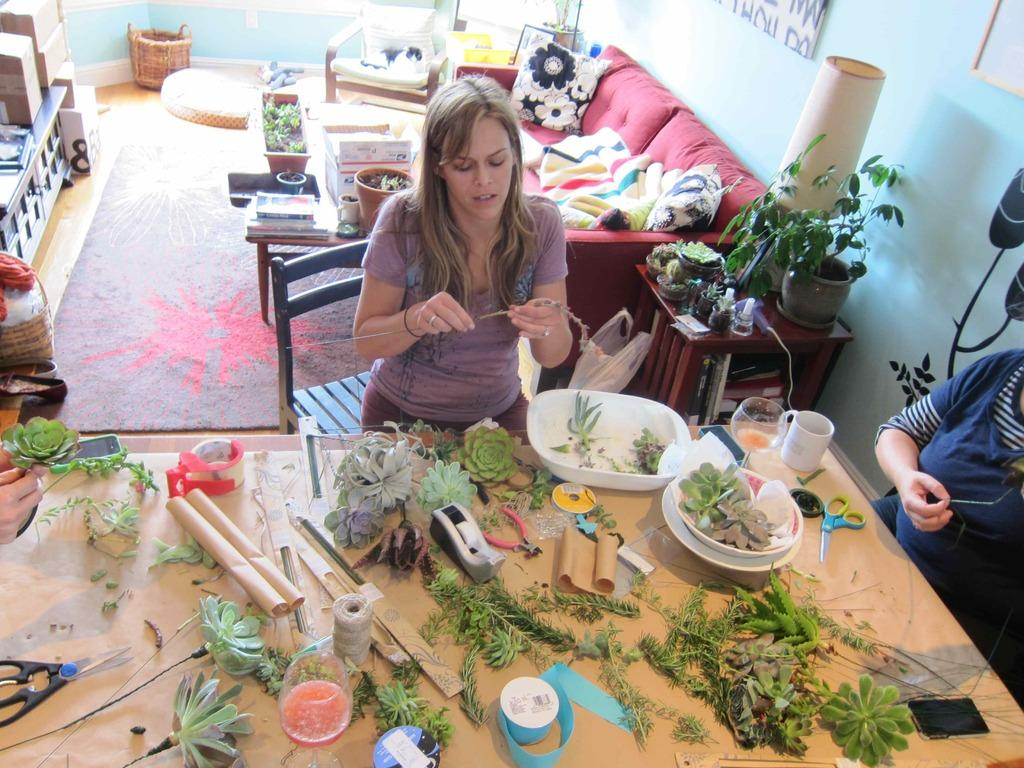What objects are on the table in the image? There are leaves, scissors, tape, a bowl, and a glass on the table in the image. What might be used for cutting in the image? Scissors are on the table, which can be used for cutting. What might be used for sticking or attaching in the image? Tape is on the table, which can be used for sticking or attaching. How many people are in the image? There are two people in the image. What can be seen in the background of the image? There is a sofa visible in the background. What type of planes can be seen flying over the market in the image? There is no market or planes visible in the image; it features a table with various objects and two people. What kind of rock is being used as a paperweight in the image? There is no rock being used as a paperweight in the image; the objects on the table include leaves, scissors, tape, a bowl, and a glass. 